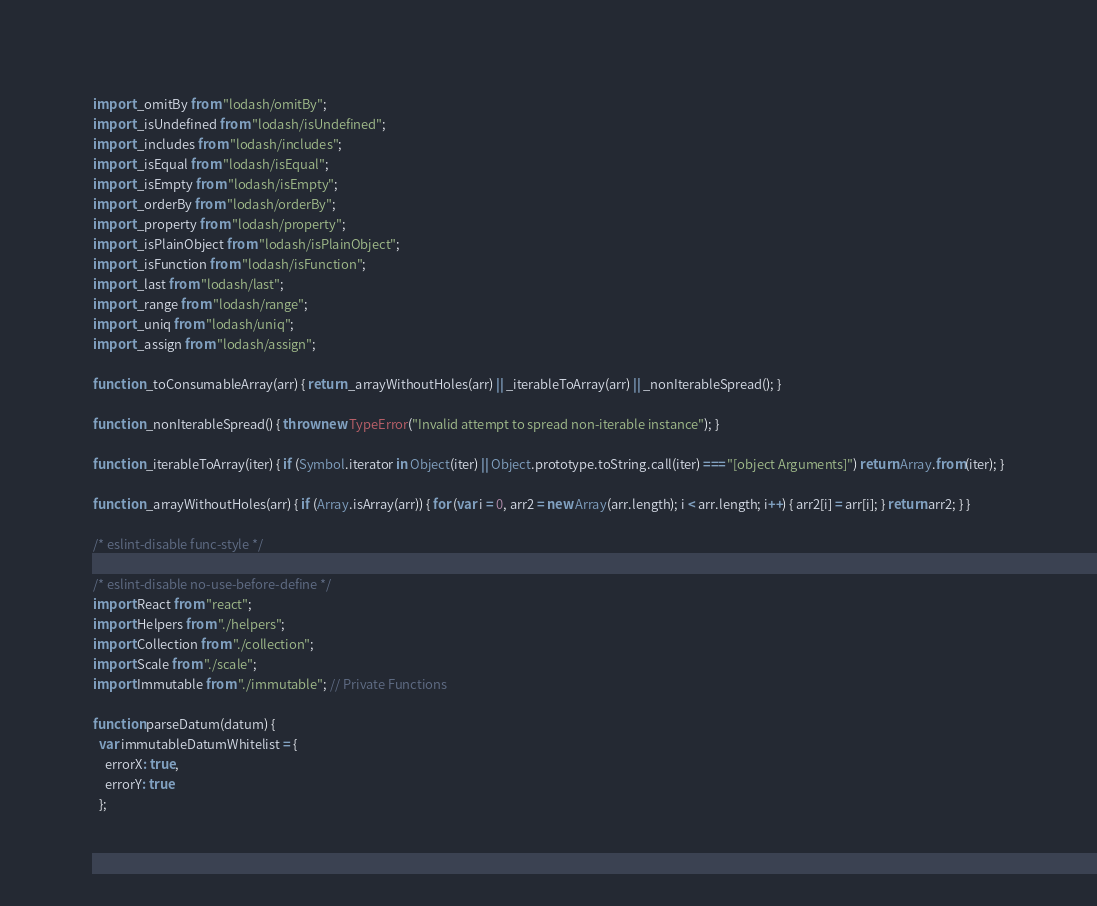<code> <loc_0><loc_0><loc_500><loc_500><_JavaScript_>import _omitBy from "lodash/omitBy";
import _isUndefined from "lodash/isUndefined";
import _includes from "lodash/includes";
import _isEqual from "lodash/isEqual";
import _isEmpty from "lodash/isEmpty";
import _orderBy from "lodash/orderBy";
import _property from "lodash/property";
import _isPlainObject from "lodash/isPlainObject";
import _isFunction from "lodash/isFunction";
import _last from "lodash/last";
import _range from "lodash/range";
import _uniq from "lodash/uniq";
import _assign from "lodash/assign";

function _toConsumableArray(arr) { return _arrayWithoutHoles(arr) || _iterableToArray(arr) || _nonIterableSpread(); }

function _nonIterableSpread() { throw new TypeError("Invalid attempt to spread non-iterable instance"); }

function _iterableToArray(iter) { if (Symbol.iterator in Object(iter) || Object.prototype.toString.call(iter) === "[object Arguments]") return Array.from(iter); }

function _arrayWithoutHoles(arr) { if (Array.isArray(arr)) { for (var i = 0, arr2 = new Array(arr.length); i < arr.length; i++) { arr2[i] = arr[i]; } return arr2; } }

/* eslint-disable func-style */

/* eslint-disable no-use-before-define */
import React from "react";
import Helpers from "./helpers";
import Collection from "./collection";
import Scale from "./scale";
import Immutable from "./immutable"; // Private Functions

function parseDatum(datum) {
  var immutableDatumWhitelist = {
    errorX: true,
    errorY: true
  };</code> 